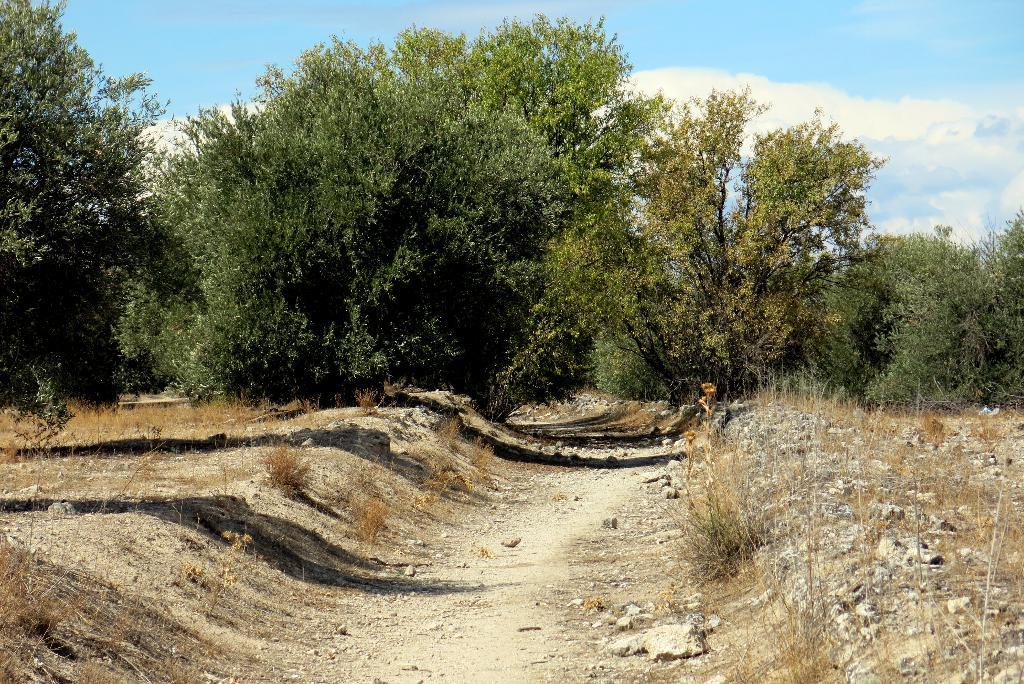What can be seen running through the landscape in the image? There is a path in the image. What type of vegetation is present on the ground on both sides of the path? Dry grass is present on the ground on both sides of the path. What can be seen in the distance in the image? There are trees in the background of the image. What is visible in the sky at the top of the image? Clouds are visible in the sky at the top of the image. What caption is written on the pipe in the image? There is no pipe present in the image, so there is no caption to be read. 